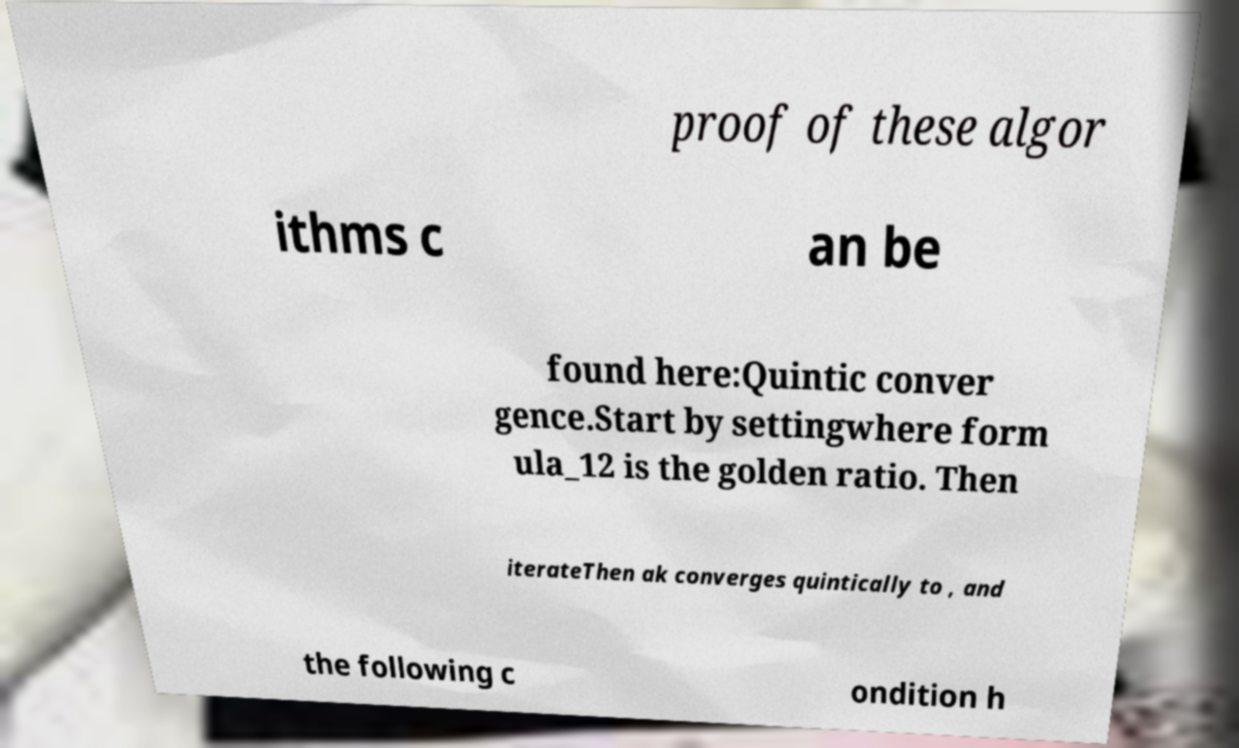Please identify and transcribe the text found in this image. proof of these algor ithms c an be found here:Quintic conver gence.Start by settingwhere form ula_12 is the golden ratio. Then iterateThen ak converges quintically to , and the following c ondition h 